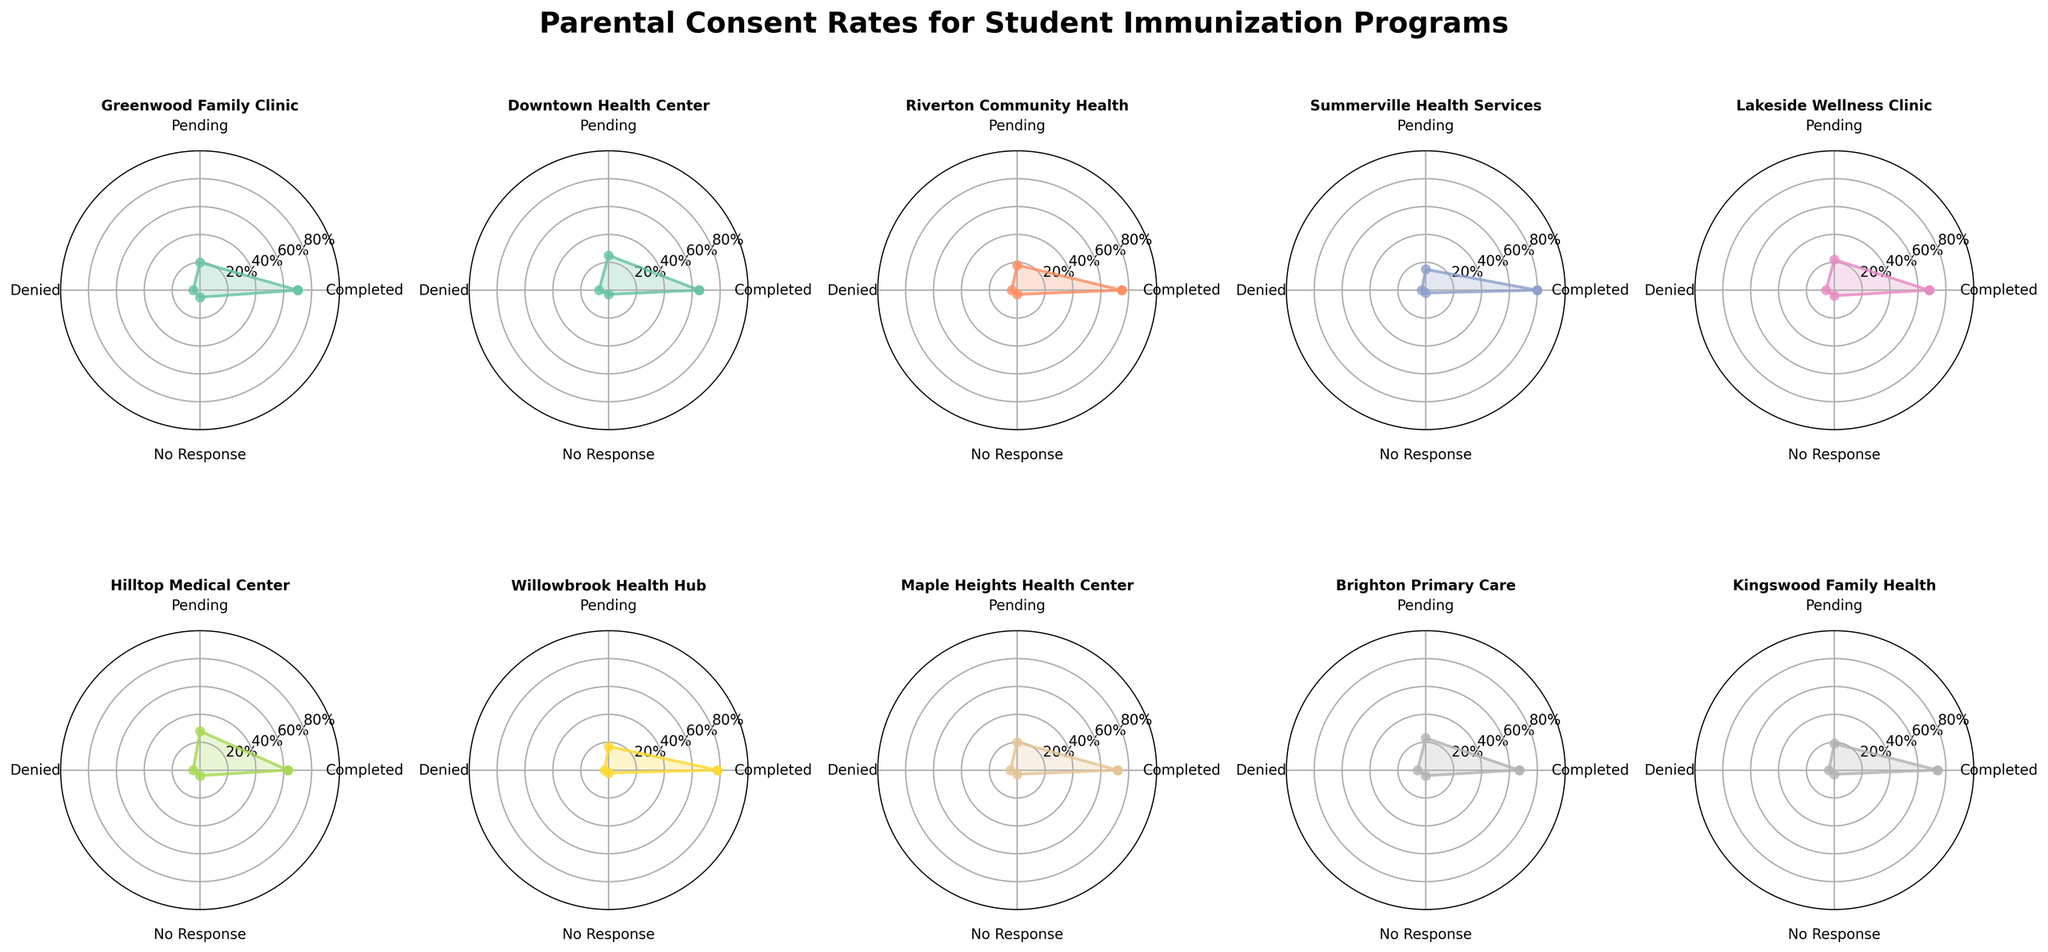What is the title of the plot? The title of the plot is placed above all the subplots. It reads "Parental Consent Rates for Student Immunization Programs," making it clear what the entire figure represents.
Answer: Parental Consent Rates for Student Immunization Programs Which health center shows the highest completed consent rate? By examining all the subplots, Summerville Health Services has the highest value for the "Completed" category, which is 80%.
Answer: Summerville Health Services What are the consent rates for Lakeside Wellness Clinic? Locate the subplot titled "Lakeside Wellness Clinic" to observe the values for each category. Completed is 68%, Pending is 22%, Denied is 6%, and No Response is 4%.
Answer: Completed: 68%, Pending: 22%, Denied: 6%, No Response: 4% How do the completed consent rates of Riverton Community Health and Kingswood Family Health compare? By looking at the subplots for both health centers, Riverton has a "Completed" rate of 75%, whereas Kingswood has 74%. Comparatively, Riverton is higher by 1%.
Answer: Riverton is higher Which health center has the lowest 'No Response' rate, and what is the value? Examining each subplot's "No Response" category, Summerville Health Services and Willowbrook Health Hub both have the lowest rate at 2%.
Answer: Summerville Health Services and Willowbrook Health Hub; 2% What is the average completed consent rate across all health centers? Add up all the "Completed" consent rates and divide by the number of health centers: (70+65+75+80+68+63+78+72+67+74)/10 = 71.2%.
Answer: 71.2% Is there a health center that has the same values for both 'Denied' and 'No Response' rates? Check for equality in the 'Denied' and 'No Response' categories in each subplot. Greenwood Family Clinic has both categories at 5%.
Answer: Greenwood Family Clinic Compare the pending consent rates between Downtown Health Center and Hilltop Medical Center. Downtown Health Center has a 'Pending' rate of 25%, while Hilltop Medical Center has 28%. Hilltop is higher by 3%.
Answer: Hilltop is higher How many health centers have a 'Completed' consent rate of 70% or higher? Check each subplot's 'Completed' category to count the number of rates 70% or higher: Greenwood, Riverton, Summerville, Willowbrook, Maple Heights, Kingswood, totaling 6.
Answer: 6 